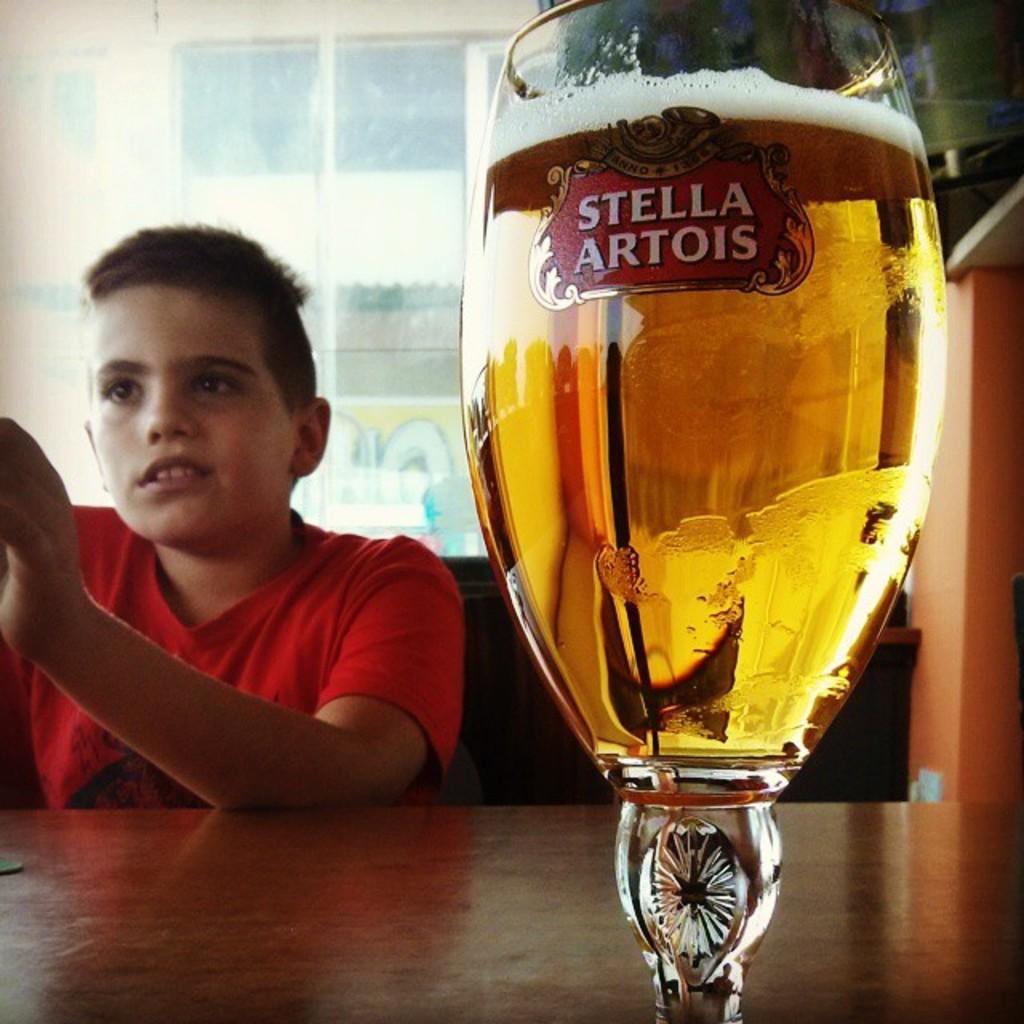Please provide a concise description of this image. In this image I can see the brown colored table and on the table I can see a wine glass with liquid in it. I can see a boy wearing red colored t shirt is sitting behind the table. In the background I can see the glass window through which I can see another building. 